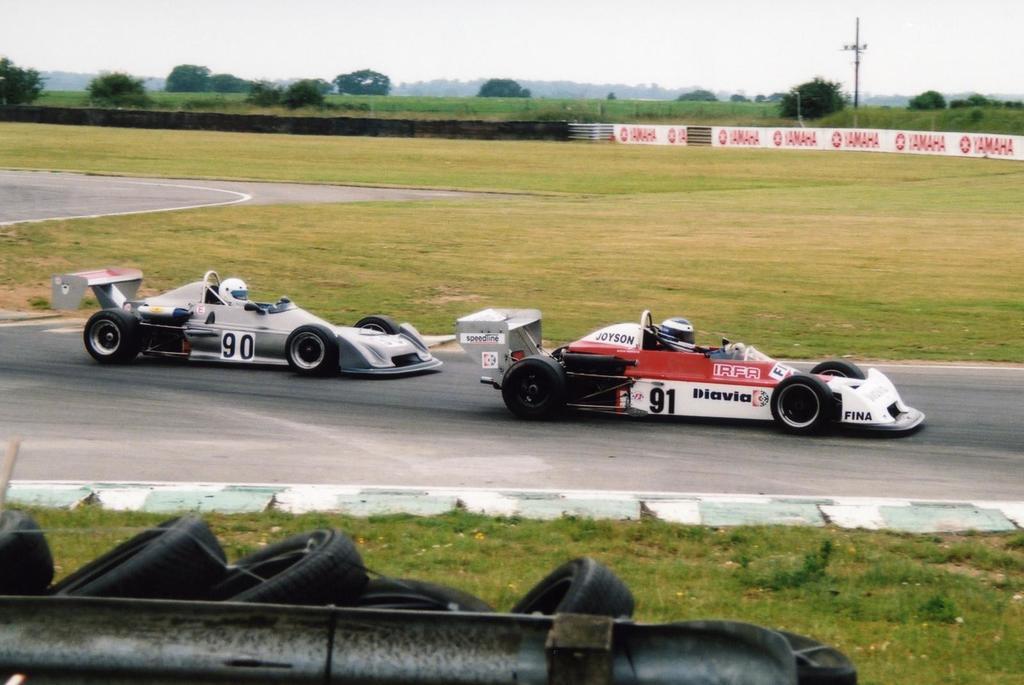How would you summarize this image in a sentence or two? At the bottom of the image there is fencing. Behind the fencing there are some tyres and there is grass. In the middle of the image there are some vehicles on the road. Behind the vehicles there is fencing. Behind the fencing there are some trees and poles. At the top of the image there is sky. 